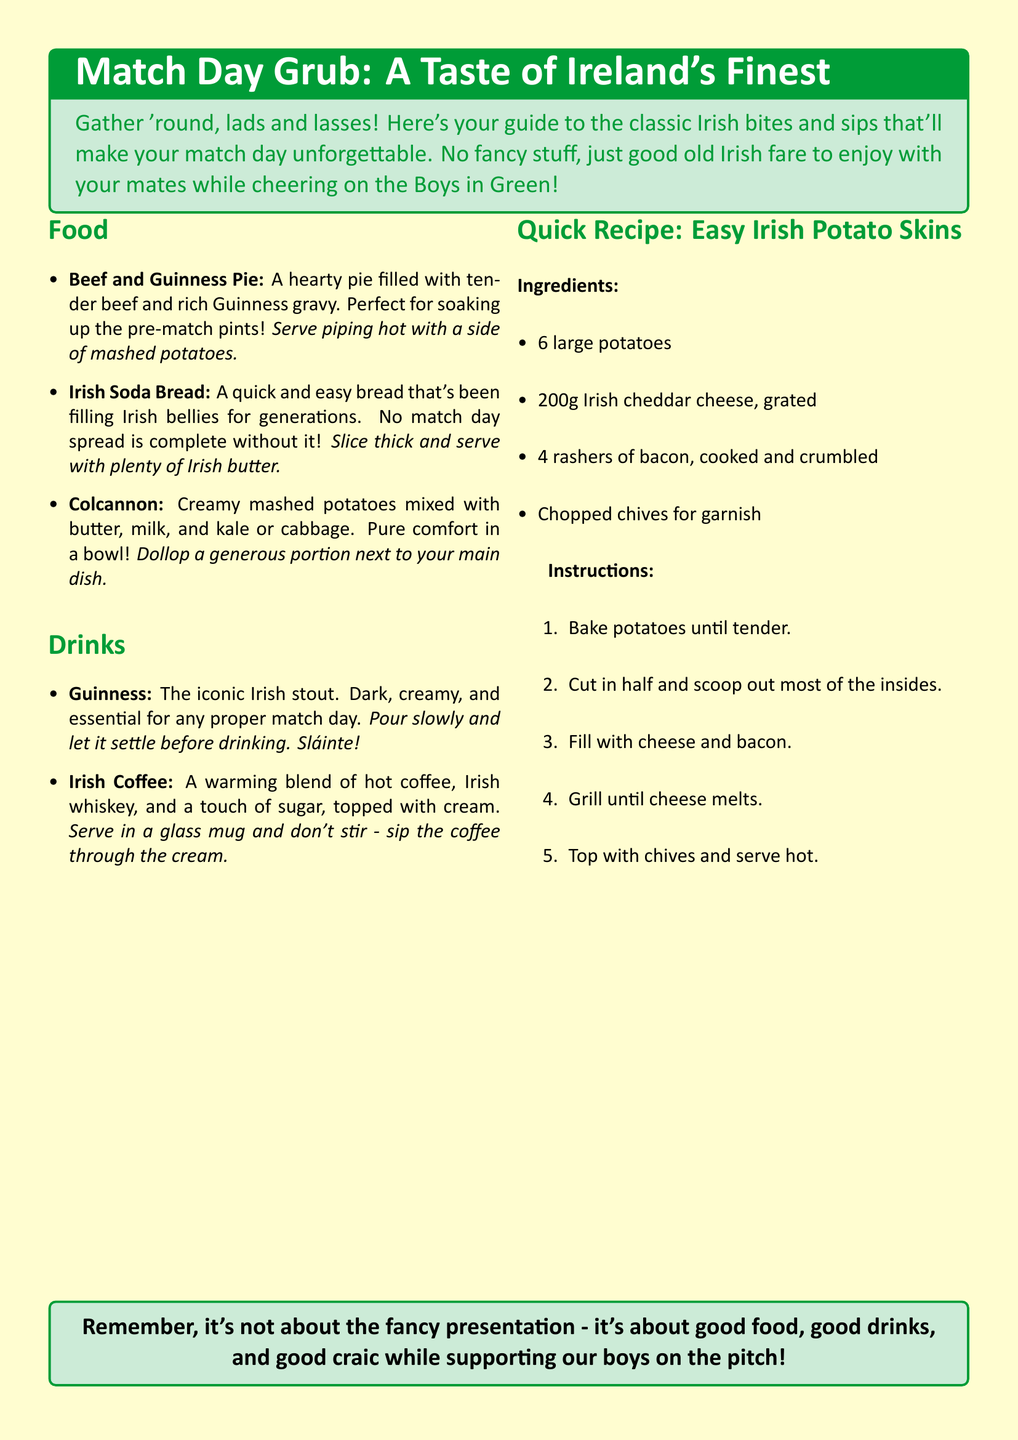What is a traditional Irish pie mentioned? The document includes Beef and Guinness Pie, which is celebrated for its hearty filling and rich gravy.
Answer: Beef and Guinness Pie What drink is essential for match day? The document lists Guinness as the iconic stout necessary for any proper match day gathering.
Answer: Guinness How many ingredients are listed for the Easy Irish Potato Skins? The recipe section indicates there are four ingredients listed for Easy Irish Potato Skins.
Answer: 4 What is served with Irish Soda Bread? The document suggests serving Irish Soda Bread with plenty of Irish butter.
Answer: Irish butter What is the main ingredient in Colcannon? The document states that Colcannon primarily consists of creamy mashed potatoes mixed with kale or cabbage.
Answer: Mashed potatoes What topping is suggested for the Easy Irish Potato Skins? The document recommends topping the potato skins with chopped chives for garnish.
Answer: Chopped chives What is the cooking instruction for the potatoes in the recipe? According to the document, the first instruction for the recipe is to bake potatoes until tender.
Answer: Bake potatoes until tender What type of drink is Irish Coffee? The document describes Irish Coffee as a warming blend of hot coffee, Irish whiskey, and a touch of sugar.
Answer: Warming blend What color is used predominantly in the catalog's background? The document specifies that the background color is cream.
Answer: Cream 